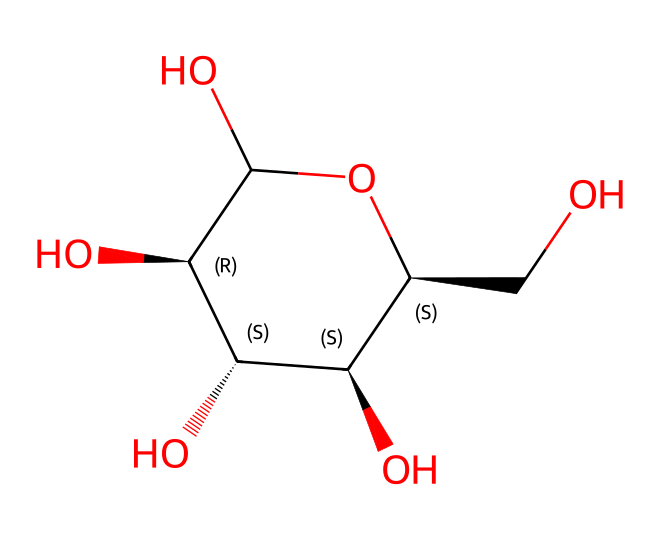What is the molecular formula of glucose? To obtain the molecular formula from the SMILES representation, analyze the structure for the number of each type of atom present. The structure includes 6 carbon atoms (C), 12 hydrogen atoms (H), and 6 oxygen atoms (O). Hence, the molecular formula is C6H12O6.
Answer: C6H12O6 How many chiral centers are present in glucose? By examining the chemical structure, identify the carbon atoms that are bonded to four different substituents. In glucose, there are four such carbon atoms that fit this criterion. Therefore, glucose has four chiral centers.
Answer: 4 What type of carbohydrate is glucose classified as? Glucose is a monosaccharide, which is a simple sugar and the most basic form of carbohydrate that cannot be hydrolyzed into simpler sugars. This classification is clear from its structure containing just one sugar unit.
Answer: monosaccharide Which functional groups are present in glucose? Analyze the structure for distinct functional groups. The SMILES indicates multiple hydroxyl (–OH) groups attached to the carbon skeleton. These hydroxyl groups characterize glucose as an alcohol, in addition to its aldehyde functional group due to the presence of an aldehyde or ketone group in their straight-chain structure.
Answer: hydroxyl and aldehyde What links the glucose molecules in polysaccharides? Polysaccharides are formed by the dehydration reactions between the hydroxyl groups of glucose, creating glycosidic bonds. These bonds are the linkages formed through the loss of water between two hydroxyl groups of glucose.
Answer: glycosidic bond What is the general role of glucose in living organisms? Glucose serves as the primary source of energy for cells in living organisms. The structure reflects its functional importance, as it is readily metabolized through various pathways to provide energy.
Answer: energy source 